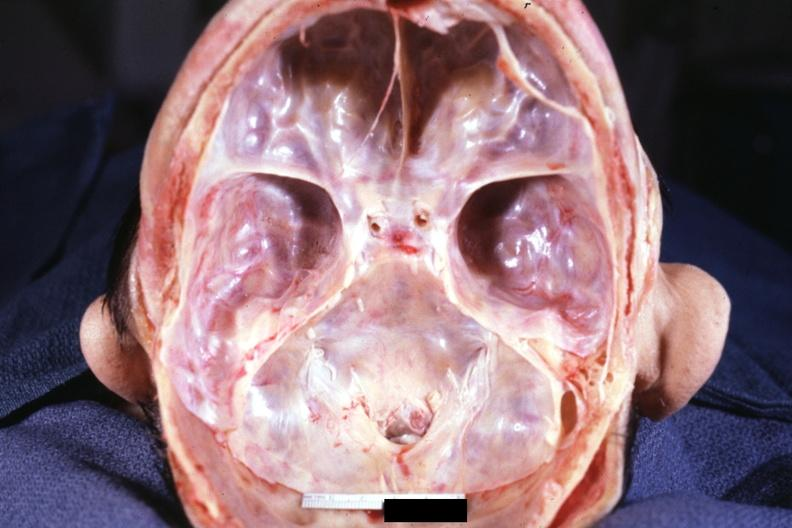s metastatic malignant melanoma present?
Answer the question using a single word or phrase. No 